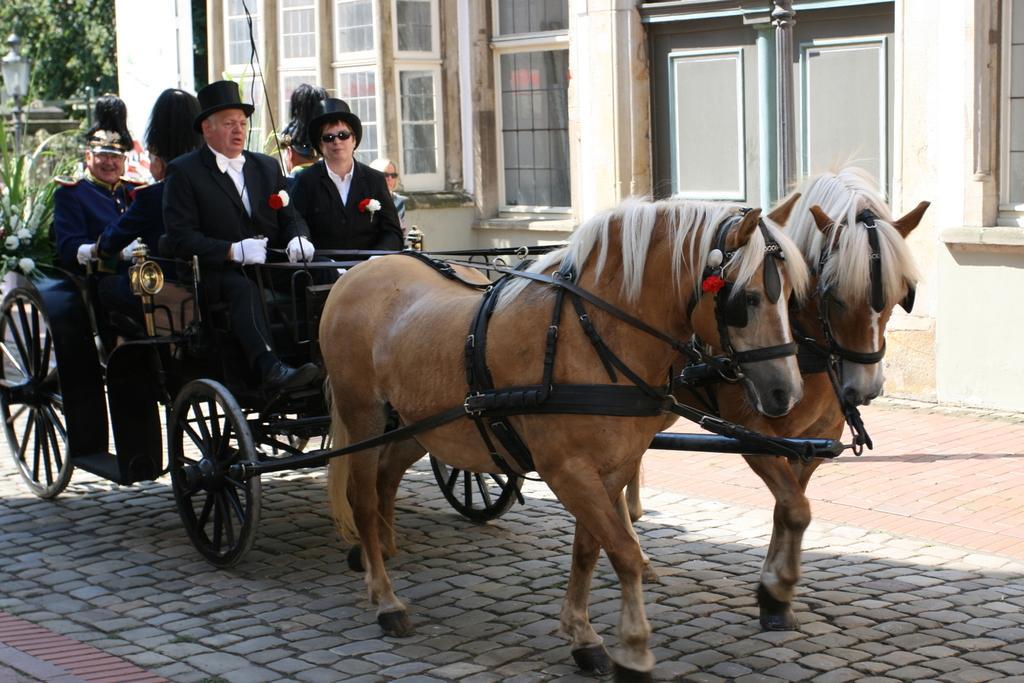In one or two sentences, can you explain what this image depicts? In this image we can see a horse cart moving on the road in which few people are sitting. In the background we can see a building and few trees. 